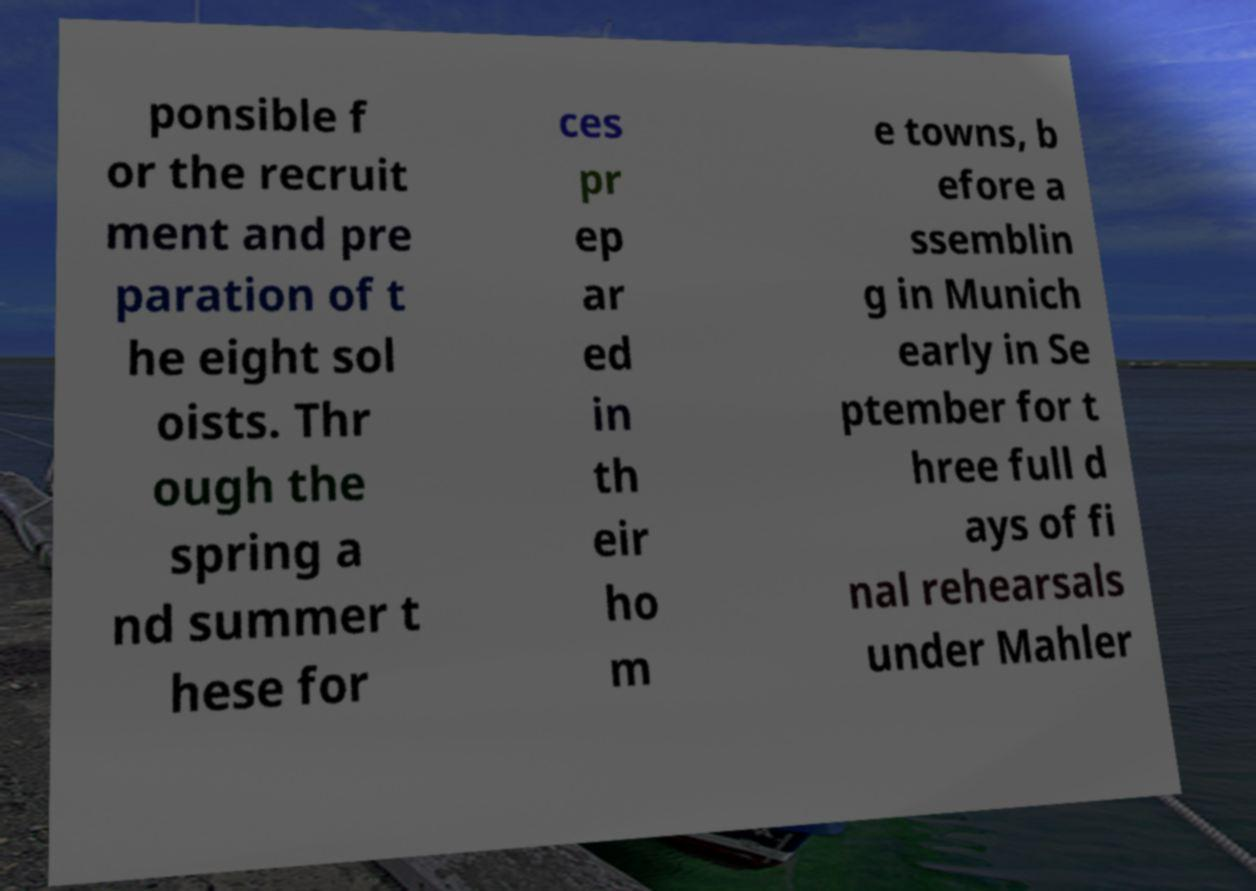Could you assist in decoding the text presented in this image and type it out clearly? ponsible f or the recruit ment and pre paration of t he eight sol oists. Thr ough the spring a nd summer t hese for ces pr ep ar ed in th eir ho m e towns, b efore a ssemblin g in Munich early in Se ptember for t hree full d ays of fi nal rehearsals under Mahler 